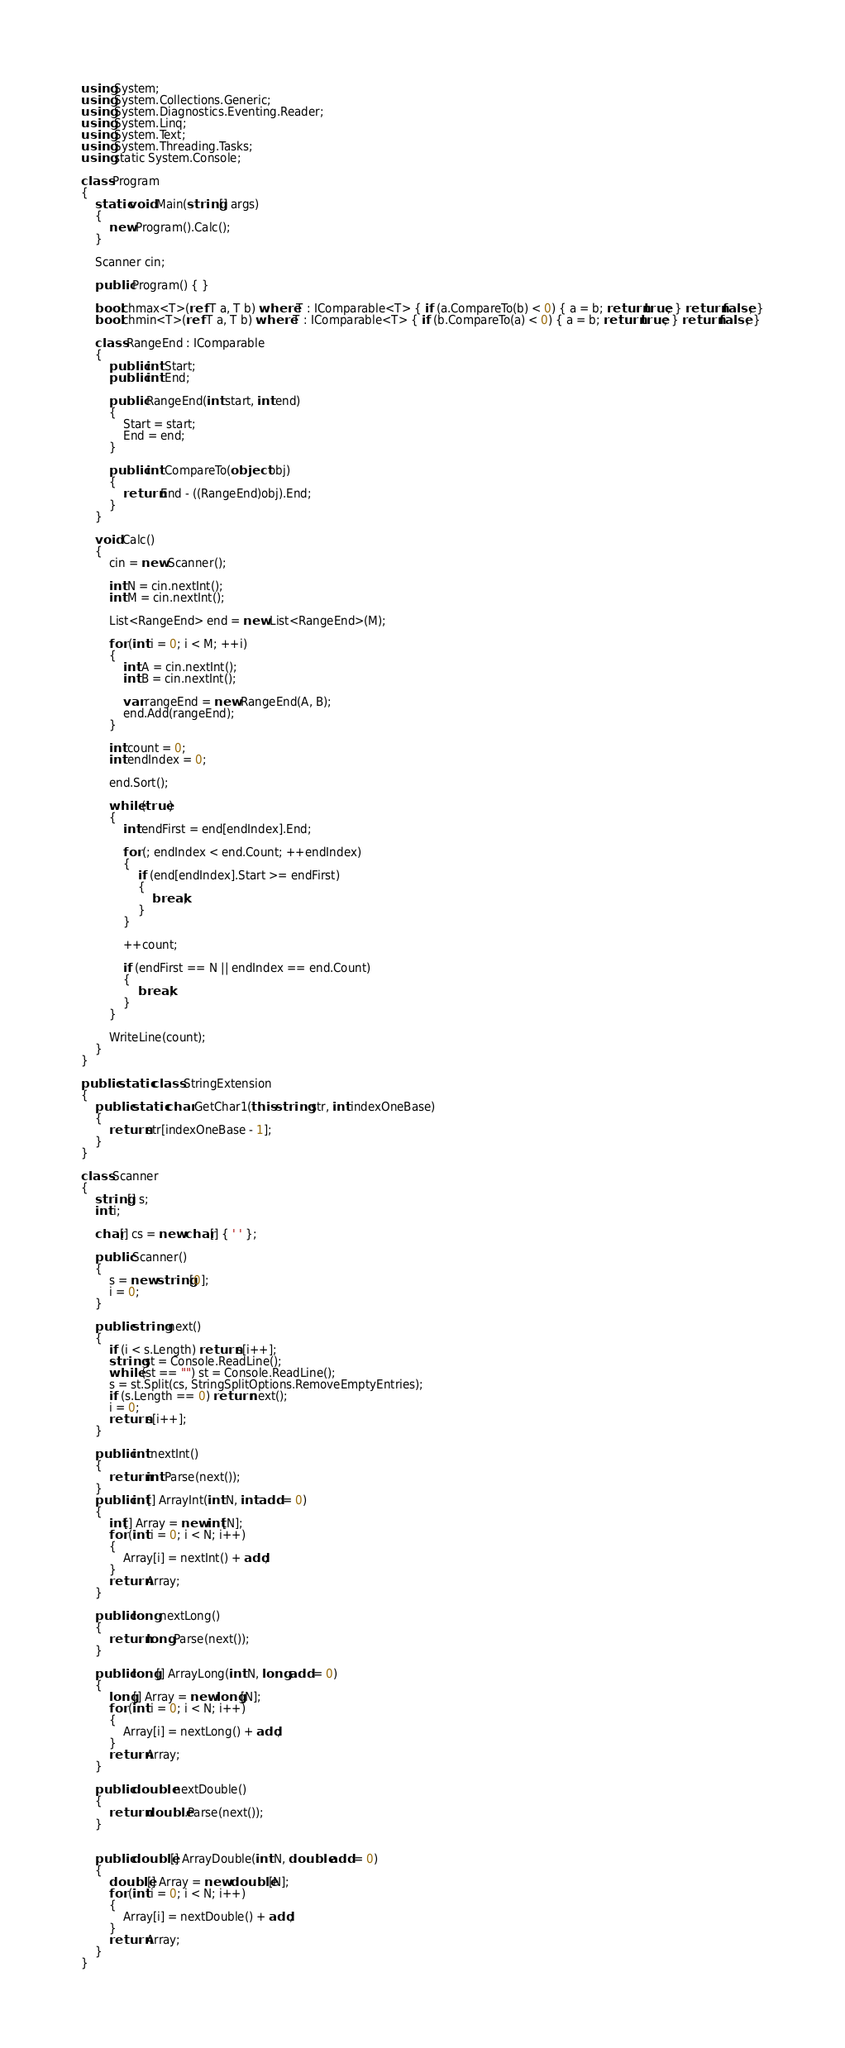<code> <loc_0><loc_0><loc_500><loc_500><_C#_>using System;
using System.Collections.Generic;
using System.Diagnostics.Eventing.Reader;
using System.Linq;
using System.Text;
using System.Threading.Tasks;
using static System.Console;

class Program
{
    static void Main(string[] args)
    {
        new Program().Calc();
    }

    Scanner cin;

    public Program() { }

    bool chmax<T>(ref T a, T b) where T : IComparable<T> { if (a.CompareTo(b) < 0) { a = b; return true; } return false; }
    bool chmin<T>(ref T a, T b) where T : IComparable<T> { if (b.CompareTo(a) < 0) { a = b; return true; } return false; }

    class RangeEnd : IComparable
    {
        public int Start;
        public int End;

        public RangeEnd(int start, int end)
        {
            Start = start;
            End = end;
        }

        public int CompareTo(object obj)
        {
            return End - ((RangeEnd)obj).End;
        }
    }

    void Calc()
    {
        cin = new Scanner();

        int N = cin.nextInt();
        int M = cin.nextInt();

        List<RangeEnd> end = new List<RangeEnd>(M);

        for (int i = 0; i < M; ++i)
        {
            int A = cin.nextInt();
            int B = cin.nextInt();

            var rangeEnd = new RangeEnd(A, B);
            end.Add(rangeEnd);
        }

        int count = 0;
        int endIndex = 0;

        end.Sort();

        while (true)
        {
            int endFirst = end[endIndex].End;

            for (; endIndex < end.Count; ++endIndex)
            {
                if (end[endIndex].Start >= endFirst)
                {
                    break;
                }
            }

            ++count;

            if (endFirst == N || endIndex == end.Count)
            {
                break;
            }
        }

        WriteLine(count);
    }
}

public static class StringExtension
{
    public static char GetChar1(this string str, int indexOneBase)
    {
        return str[indexOneBase - 1];
    }
}

class Scanner
{
    string[] s;
    int i;

    char[] cs = new char[] { ' ' };

    public Scanner()
    {
        s = new string[0];
        i = 0;
    }

    public string next()
    {
        if (i < s.Length) return s[i++];
        string st = Console.ReadLine();
        while (st == "") st = Console.ReadLine();
        s = st.Split(cs, StringSplitOptions.RemoveEmptyEntries);
        if (s.Length == 0) return next();
        i = 0;
        return s[i++];
    }

    public int nextInt()
    {
        return int.Parse(next());
    }
    public int[] ArrayInt(int N, int add = 0)
    {
        int[] Array = new int[N];
        for (int i = 0; i < N; i++)
        {
            Array[i] = nextInt() + add;
        }
        return Array;
    }

    public long nextLong()
    {
        return long.Parse(next());
    }

    public long[] ArrayLong(int N, long add = 0)
    {
        long[] Array = new long[N];
        for (int i = 0; i < N; i++)
        {
            Array[i] = nextLong() + add;
        }
        return Array;
    }

    public double nextDouble()
    {
        return double.Parse(next());
    }


    public double[] ArrayDouble(int N, double add = 0)
    {
        double[] Array = new double[N];
        for (int i = 0; i < N; i++)
        {
            Array[i] = nextDouble() + add;
        }
        return Array;
    }
}
</code> 